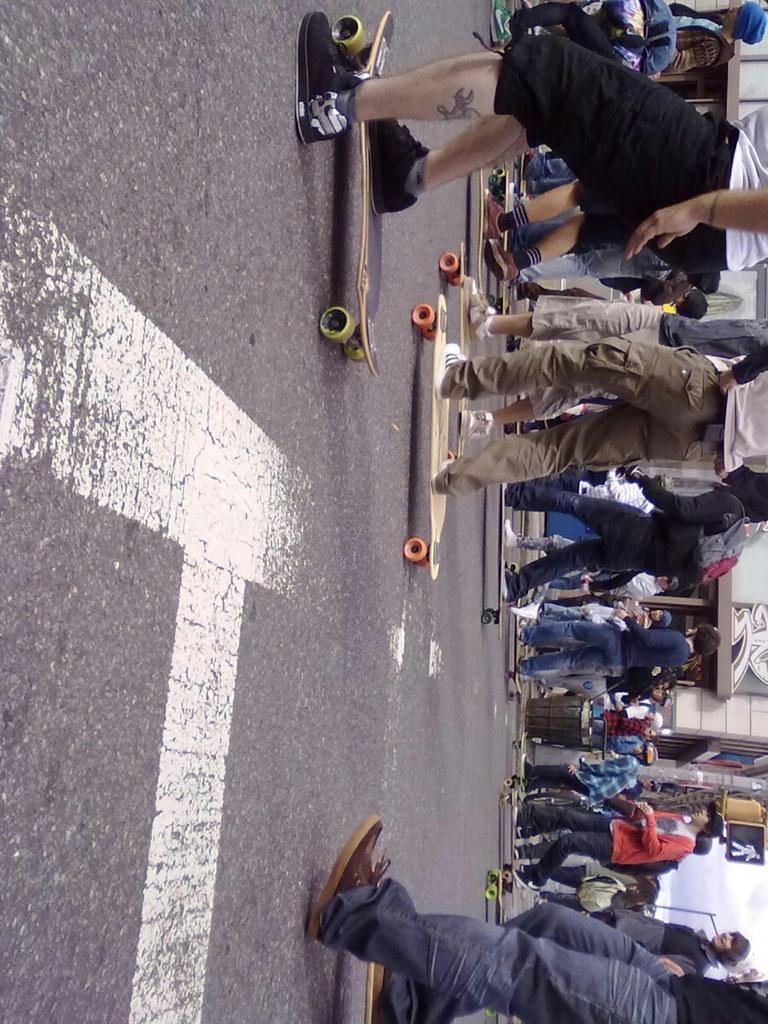Could you give a brief overview of what you see in this image? In this image we can see a group of people skating on the road. 